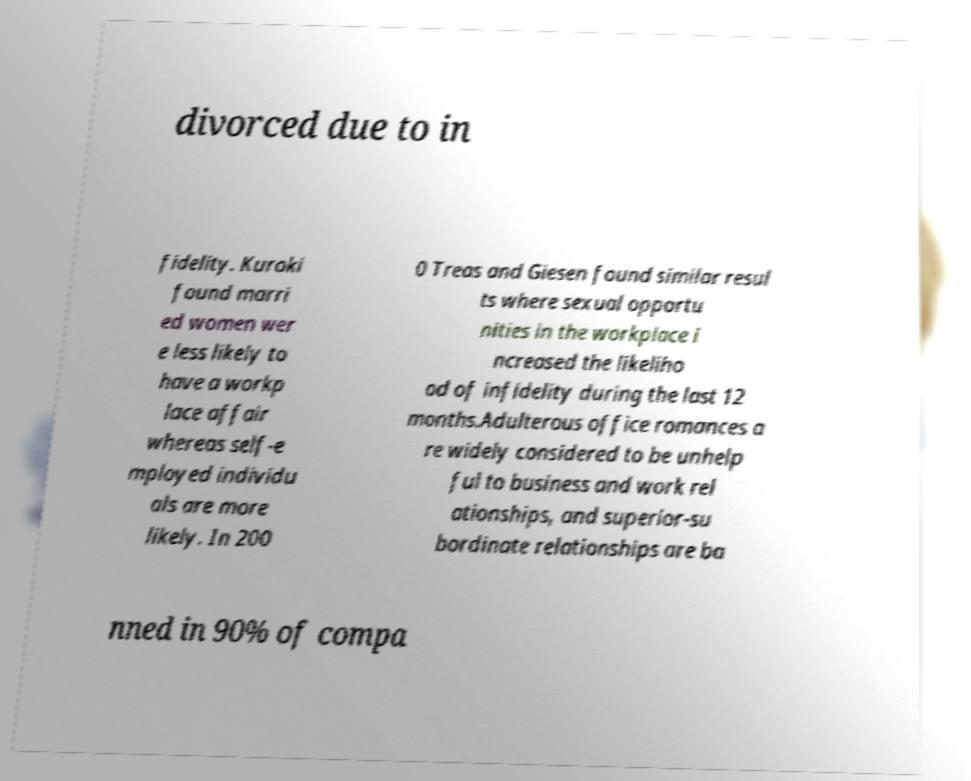There's text embedded in this image that I need extracted. Can you transcribe it verbatim? divorced due to in fidelity. Kuroki found marri ed women wer e less likely to have a workp lace affair whereas self-e mployed individu als are more likely. In 200 0 Treas and Giesen found similar resul ts where sexual opportu nities in the workplace i ncreased the likeliho od of infidelity during the last 12 months.Adulterous office romances a re widely considered to be unhelp ful to business and work rel ationships, and superior-su bordinate relationships are ba nned in 90% of compa 